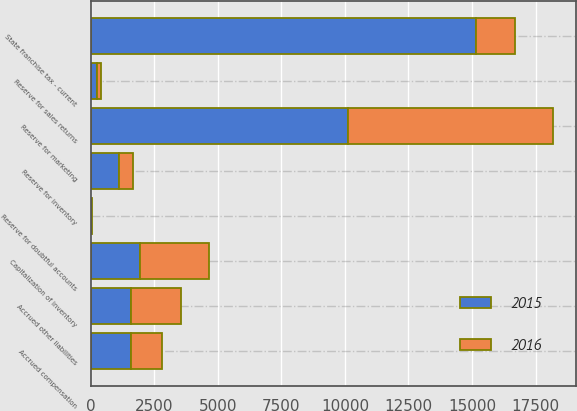Convert chart to OTSL. <chart><loc_0><loc_0><loc_500><loc_500><stacked_bar_chart><ecel><fcel>Reserve for sales returns<fcel>Reserve for doubtful accounts<fcel>Reserve for inventory<fcel>Reserve for marketing<fcel>Capitalization of inventory<fcel>State franchise tax - current<fcel>Accrued compensation<fcel>Accrued other liabilities<nl><fcel>2016<fcel>149<fcel>21<fcel>524<fcel>8065<fcel>2714<fcel>1565<fcel>1212<fcel>1967<nl><fcel>2015<fcel>242<fcel>18<fcel>1126<fcel>10118<fcel>1927<fcel>15143<fcel>1584<fcel>1565<nl></chart> 